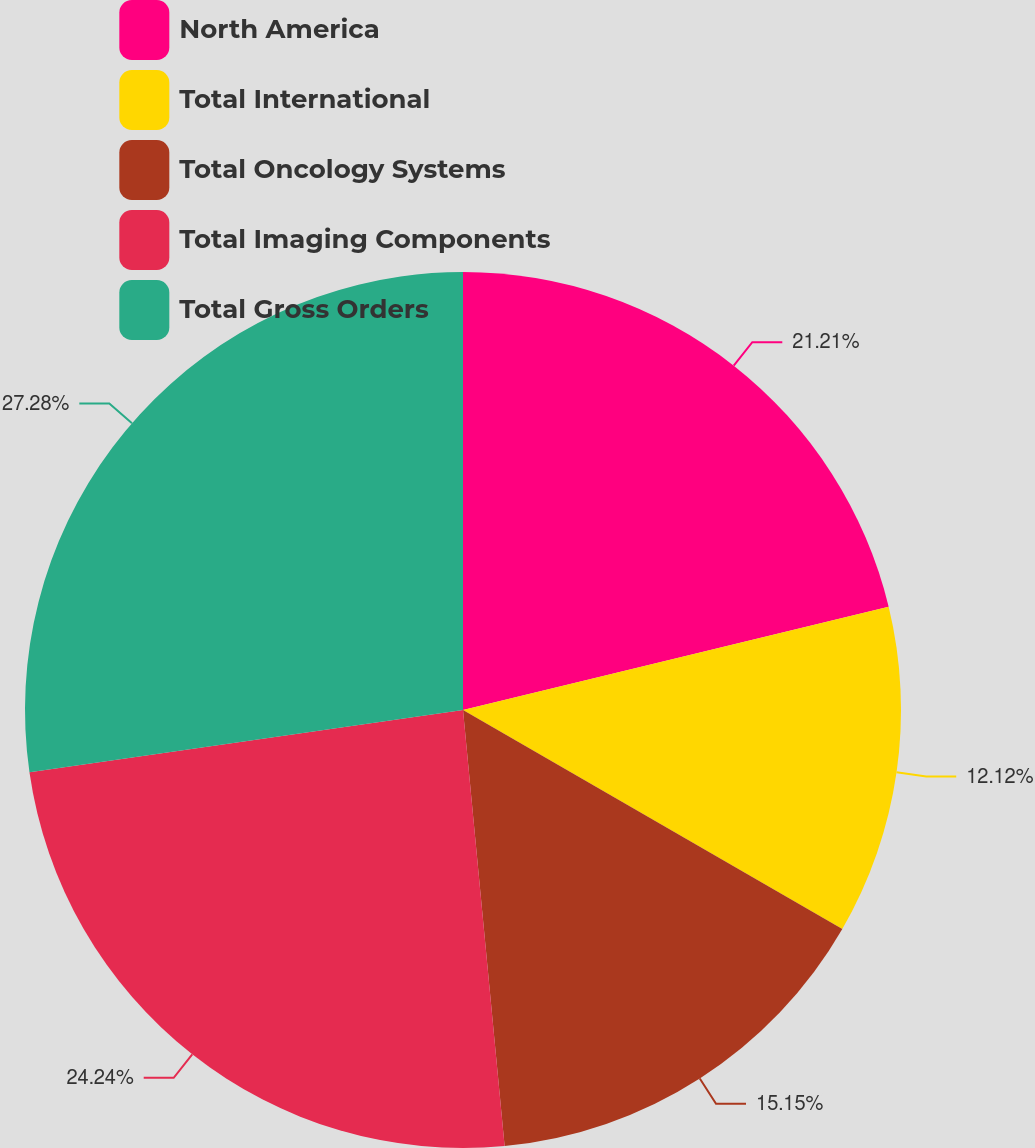<chart> <loc_0><loc_0><loc_500><loc_500><pie_chart><fcel>North America<fcel>Total International<fcel>Total Oncology Systems<fcel>Total Imaging Components<fcel>Total Gross Orders<nl><fcel>21.21%<fcel>12.12%<fcel>15.15%<fcel>24.24%<fcel>27.27%<nl></chart> 